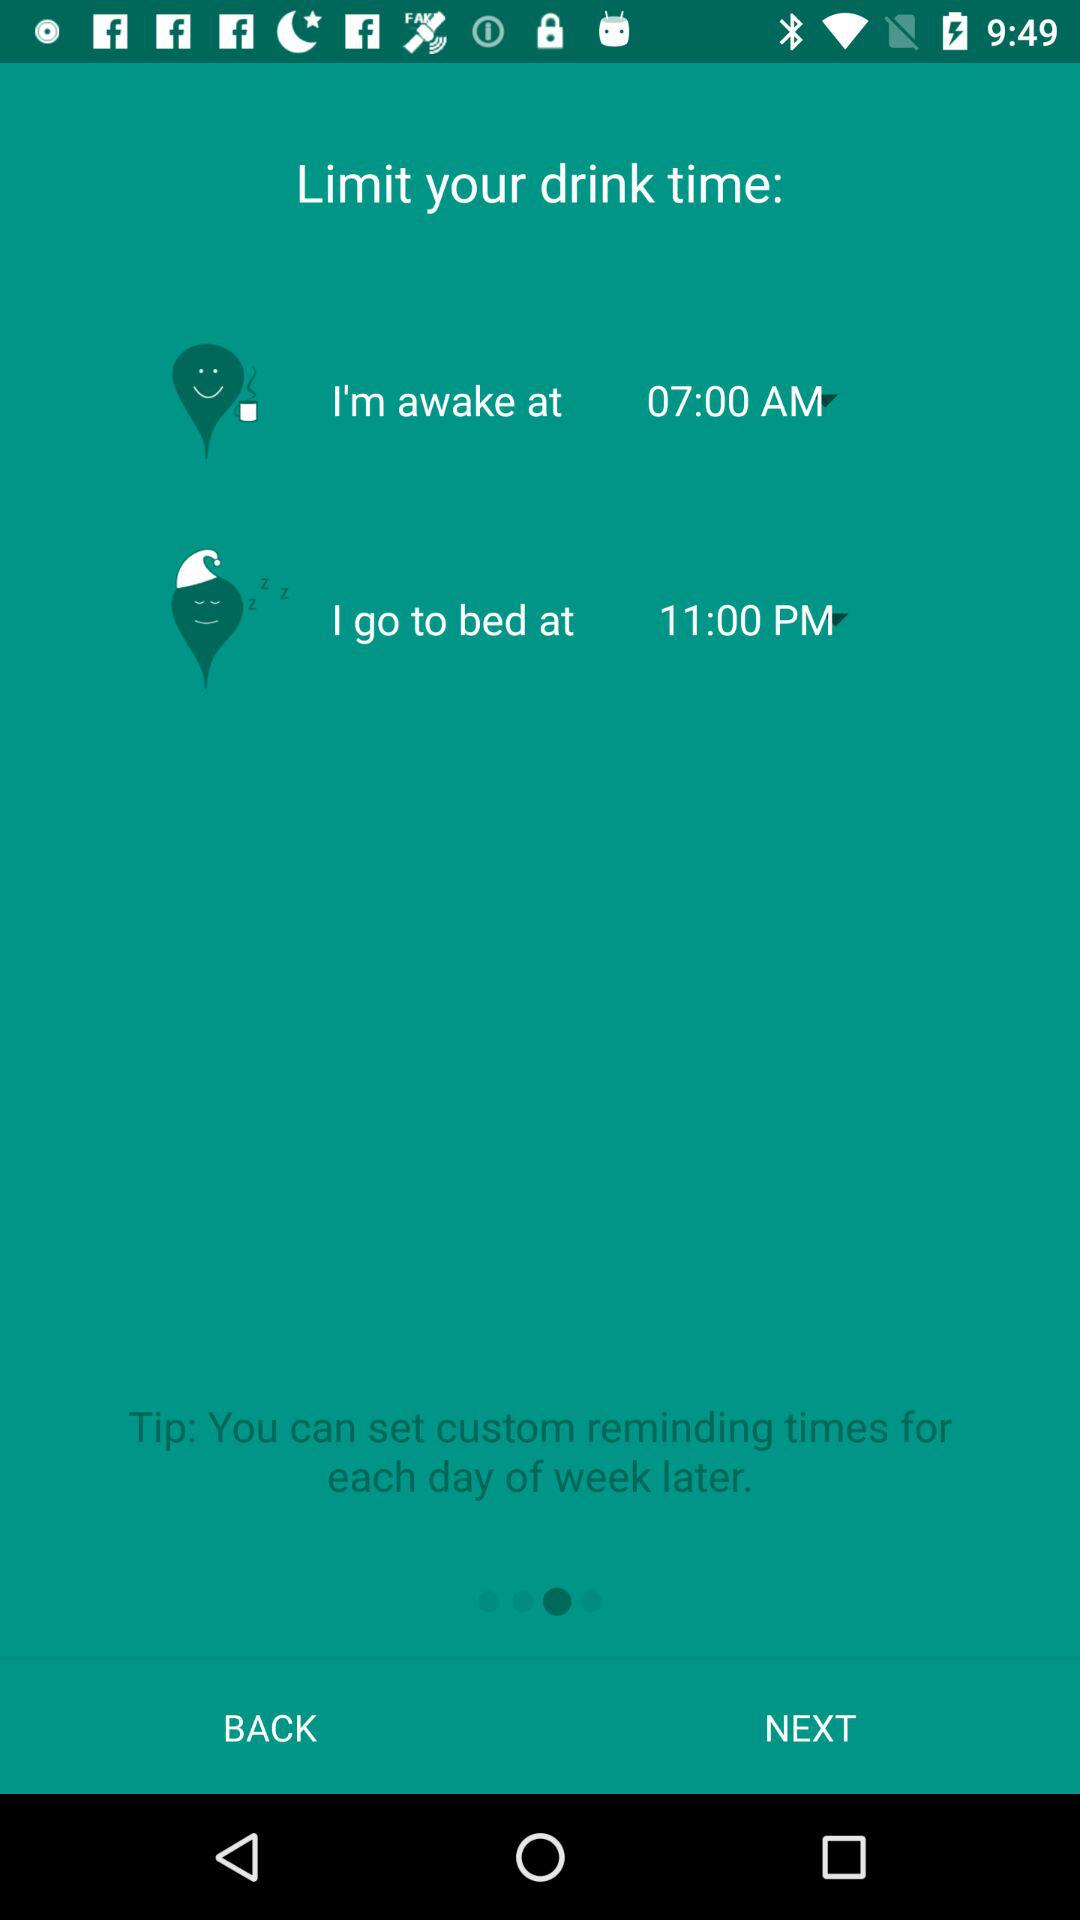What is awake time? The awake time is 07:00 AM. 